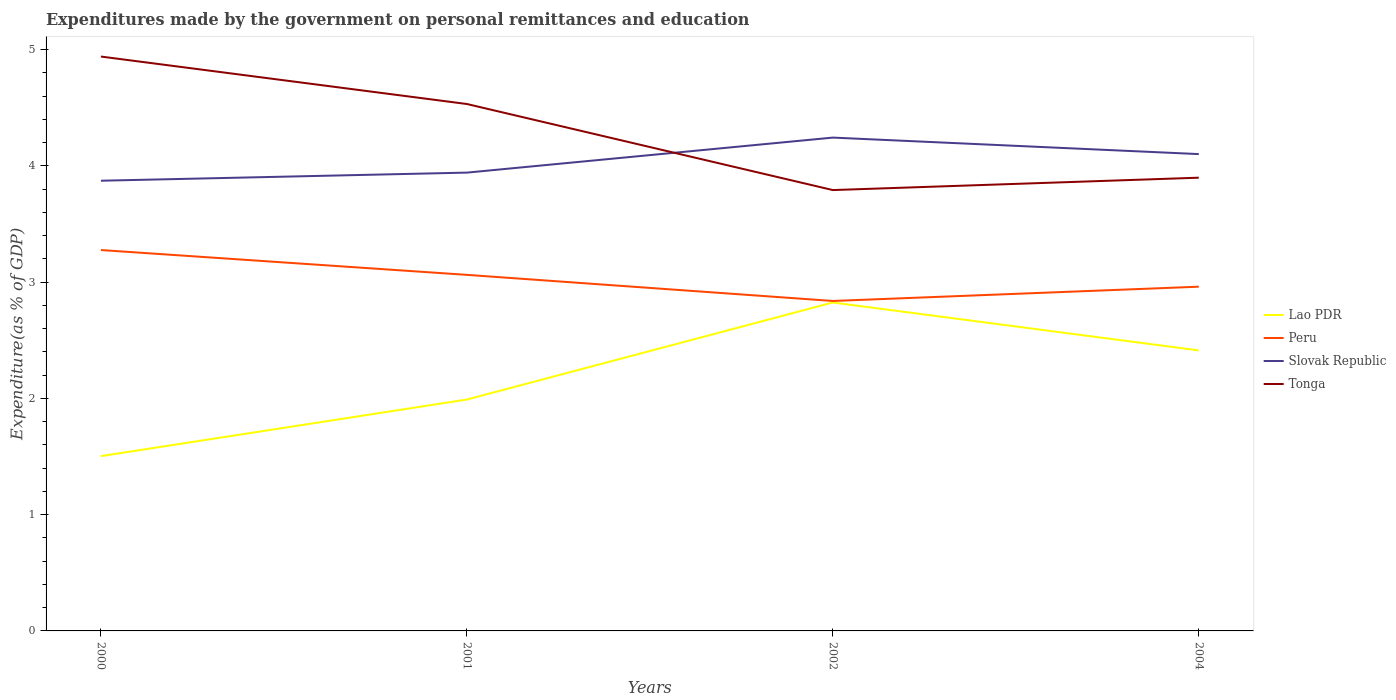How many different coloured lines are there?
Provide a short and direct response. 4. Does the line corresponding to Tonga intersect with the line corresponding to Lao PDR?
Ensure brevity in your answer.  No. Is the number of lines equal to the number of legend labels?
Give a very brief answer. Yes. Across all years, what is the maximum expenditures made by the government on personal remittances and education in Slovak Republic?
Give a very brief answer. 3.87. In which year was the expenditures made by the government on personal remittances and education in Tonga maximum?
Give a very brief answer. 2002. What is the total expenditures made by the government on personal remittances and education in Tonga in the graph?
Provide a succinct answer. 1.15. What is the difference between the highest and the second highest expenditures made by the government on personal remittances and education in Peru?
Offer a very short reply. 0.44. What is the difference between the highest and the lowest expenditures made by the government on personal remittances and education in Slovak Republic?
Ensure brevity in your answer.  2. Is the expenditures made by the government on personal remittances and education in Slovak Republic strictly greater than the expenditures made by the government on personal remittances and education in Peru over the years?
Your answer should be very brief. No. Does the graph contain any zero values?
Keep it short and to the point. No. Does the graph contain grids?
Your response must be concise. No. How are the legend labels stacked?
Offer a very short reply. Vertical. What is the title of the graph?
Make the answer very short. Expenditures made by the government on personal remittances and education. What is the label or title of the Y-axis?
Offer a very short reply. Expenditure(as % of GDP). What is the Expenditure(as % of GDP) in Lao PDR in 2000?
Your answer should be compact. 1.5. What is the Expenditure(as % of GDP) of Peru in 2000?
Provide a succinct answer. 3.28. What is the Expenditure(as % of GDP) of Slovak Republic in 2000?
Your response must be concise. 3.87. What is the Expenditure(as % of GDP) of Tonga in 2000?
Ensure brevity in your answer.  4.94. What is the Expenditure(as % of GDP) in Lao PDR in 2001?
Offer a very short reply. 1.99. What is the Expenditure(as % of GDP) in Peru in 2001?
Keep it short and to the point. 3.06. What is the Expenditure(as % of GDP) in Slovak Republic in 2001?
Keep it short and to the point. 3.94. What is the Expenditure(as % of GDP) in Tonga in 2001?
Your answer should be compact. 4.53. What is the Expenditure(as % of GDP) of Lao PDR in 2002?
Offer a very short reply. 2.83. What is the Expenditure(as % of GDP) in Peru in 2002?
Offer a terse response. 2.84. What is the Expenditure(as % of GDP) in Slovak Republic in 2002?
Ensure brevity in your answer.  4.24. What is the Expenditure(as % of GDP) of Tonga in 2002?
Provide a short and direct response. 3.79. What is the Expenditure(as % of GDP) of Lao PDR in 2004?
Provide a succinct answer. 2.41. What is the Expenditure(as % of GDP) of Peru in 2004?
Your answer should be compact. 2.96. What is the Expenditure(as % of GDP) in Slovak Republic in 2004?
Your answer should be very brief. 4.1. What is the Expenditure(as % of GDP) in Tonga in 2004?
Offer a very short reply. 3.9. Across all years, what is the maximum Expenditure(as % of GDP) of Lao PDR?
Your response must be concise. 2.83. Across all years, what is the maximum Expenditure(as % of GDP) of Peru?
Your answer should be very brief. 3.28. Across all years, what is the maximum Expenditure(as % of GDP) in Slovak Republic?
Offer a very short reply. 4.24. Across all years, what is the maximum Expenditure(as % of GDP) of Tonga?
Provide a succinct answer. 4.94. Across all years, what is the minimum Expenditure(as % of GDP) of Lao PDR?
Keep it short and to the point. 1.5. Across all years, what is the minimum Expenditure(as % of GDP) of Peru?
Provide a short and direct response. 2.84. Across all years, what is the minimum Expenditure(as % of GDP) in Slovak Republic?
Ensure brevity in your answer.  3.87. Across all years, what is the minimum Expenditure(as % of GDP) of Tonga?
Your answer should be compact. 3.79. What is the total Expenditure(as % of GDP) in Lao PDR in the graph?
Ensure brevity in your answer.  8.73. What is the total Expenditure(as % of GDP) of Peru in the graph?
Offer a terse response. 12.14. What is the total Expenditure(as % of GDP) in Slovak Republic in the graph?
Ensure brevity in your answer.  16.16. What is the total Expenditure(as % of GDP) of Tonga in the graph?
Provide a succinct answer. 17.16. What is the difference between the Expenditure(as % of GDP) of Lao PDR in 2000 and that in 2001?
Offer a very short reply. -0.49. What is the difference between the Expenditure(as % of GDP) of Peru in 2000 and that in 2001?
Your response must be concise. 0.21. What is the difference between the Expenditure(as % of GDP) of Slovak Republic in 2000 and that in 2001?
Offer a terse response. -0.07. What is the difference between the Expenditure(as % of GDP) of Tonga in 2000 and that in 2001?
Make the answer very short. 0.41. What is the difference between the Expenditure(as % of GDP) in Lao PDR in 2000 and that in 2002?
Keep it short and to the point. -1.32. What is the difference between the Expenditure(as % of GDP) in Peru in 2000 and that in 2002?
Make the answer very short. 0.44. What is the difference between the Expenditure(as % of GDP) in Slovak Republic in 2000 and that in 2002?
Keep it short and to the point. -0.37. What is the difference between the Expenditure(as % of GDP) in Tonga in 2000 and that in 2002?
Offer a very short reply. 1.15. What is the difference between the Expenditure(as % of GDP) in Lao PDR in 2000 and that in 2004?
Offer a terse response. -0.91. What is the difference between the Expenditure(as % of GDP) in Peru in 2000 and that in 2004?
Make the answer very short. 0.32. What is the difference between the Expenditure(as % of GDP) of Slovak Republic in 2000 and that in 2004?
Offer a very short reply. -0.23. What is the difference between the Expenditure(as % of GDP) of Tonga in 2000 and that in 2004?
Your answer should be compact. 1.04. What is the difference between the Expenditure(as % of GDP) in Lao PDR in 2001 and that in 2002?
Your answer should be compact. -0.83. What is the difference between the Expenditure(as % of GDP) of Peru in 2001 and that in 2002?
Your answer should be compact. 0.22. What is the difference between the Expenditure(as % of GDP) of Slovak Republic in 2001 and that in 2002?
Offer a terse response. -0.3. What is the difference between the Expenditure(as % of GDP) in Tonga in 2001 and that in 2002?
Your response must be concise. 0.74. What is the difference between the Expenditure(as % of GDP) of Lao PDR in 2001 and that in 2004?
Your answer should be compact. -0.42. What is the difference between the Expenditure(as % of GDP) in Peru in 2001 and that in 2004?
Offer a terse response. 0.1. What is the difference between the Expenditure(as % of GDP) of Slovak Republic in 2001 and that in 2004?
Offer a terse response. -0.16. What is the difference between the Expenditure(as % of GDP) of Tonga in 2001 and that in 2004?
Offer a very short reply. 0.63. What is the difference between the Expenditure(as % of GDP) of Lao PDR in 2002 and that in 2004?
Provide a short and direct response. 0.41. What is the difference between the Expenditure(as % of GDP) in Peru in 2002 and that in 2004?
Provide a succinct answer. -0.12. What is the difference between the Expenditure(as % of GDP) in Slovak Republic in 2002 and that in 2004?
Ensure brevity in your answer.  0.14. What is the difference between the Expenditure(as % of GDP) of Tonga in 2002 and that in 2004?
Offer a terse response. -0.11. What is the difference between the Expenditure(as % of GDP) of Lao PDR in 2000 and the Expenditure(as % of GDP) of Peru in 2001?
Keep it short and to the point. -1.56. What is the difference between the Expenditure(as % of GDP) in Lao PDR in 2000 and the Expenditure(as % of GDP) in Slovak Republic in 2001?
Make the answer very short. -2.44. What is the difference between the Expenditure(as % of GDP) of Lao PDR in 2000 and the Expenditure(as % of GDP) of Tonga in 2001?
Offer a terse response. -3.03. What is the difference between the Expenditure(as % of GDP) of Peru in 2000 and the Expenditure(as % of GDP) of Slovak Republic in 2001?
Offer a very short reply. -0.67. What is the difference between the Expenditure(as % of GDP) of Peru in 2000 and the Expenditure(as % of GDP) of Tonga in 2001?
Offer a very short reply. -1.26. What is the difference between the Expenditure(as % of GDP) of Slovak Republic in 2000 and the Expenditure(as % of GDP) of Tonga in 2001?
Your answer should be very brief. -0.66. What is the difference between the Expenditure(as % of GDP) of Lao PDR in 2000 and the Expenditure(as % of GDP) of Peru in 2002?
Offer a terse response. -1.33. What is the difference between the Expenditure(as % of GDP) in Lao PDR in 2000 and the Expenditure(as % of GDP) in Slovak Republic in 2002?
Make the answer very short. -2.74. What is the difference between the Expenditure(as % of GDP) in Lao PDR in 2000 and the Expenditure(as % of GDP) in Tonga in 2002?
Provide a succinct answer. -2.29. What is the difference between the Expenditure(as % of GDP) in Peru in 2000 and the Expenditure(as % of GDP) in Slovak Republic in 2002?
Your answer should be compact. -0.97. What is the difference between the Expenditure(as % of GDP) of Peru in 2000 and the Expenditure(as % of GDP) of Tonga in 2002?
Offer a terse response. -0.52. What is the difference between the Expenditure(as % of GDP) in Slovak Republic in 2000 and the Expenditure(as % of GDP) in Tonga in 2002?
Your response must be concise. 0.08. What is the difference between the Expenditure(as % of GDP) of Lao PDR in 2000 and the Expenditure(as % of GDP) of Peru in 2004?
Your answer should be very brief. -1.46. What is the difference between the Expenditure(as % of GDP) in Lao PDR in 2000 and the Expenditure(as % of GDP) in Slovak Republic in 2004?
Give a very brief answer. -2.6. What is the difference between the Expenditure(as % of GDP) in Lao PDR in 2000 and the Expenditure(as % of GDP) in Tonga in 2004?
Your answer should be compact. -2.4. What is the difference between the Expenditure(as % of GDP) in Peru in 2000 and the Expenditure(as % of GDP) in Slovak Republic in 2004?
Offer a very short reply. -0.83. What is the difference between the Expenditure(as % of GDP) of Peru in 2000 and the Expenditure(as % of GDP) of Tonga in 2004?
Give a very brief answer. -0.62. What is the difference between the Expenditure(as % of GDP) in Slovak Republic in 2000 and the Expenditure(as % of GDP) in Tonga in 2004?
Provide a succinct answer. -0.03. What is the difference between the Expenditure(as % of GDP) in Lao PDR in 2001 and the Expenditure(as % of GDP) in Peru in 2002?
Provide a succinct answer. -0.85. What is the difference between the Expenditure(as % of GDP) in Lao PDR in 2001 and the Expenditure(as % of GDP) in Slovak Republic in 2002?
Make the answer very short. -2.25. What is the difference between the Expenditure(as % of GDP) of Lao PDR in 2001 and the Expenditure(as % of GDP) of Tonga in 2002?
Your response must be concise. -1.8. What is the difference between the Expenditure(as % of GDP) in Peru in 2001 and the Expenditure(as % of GDP) in Slovak Republic in 2002?
Keep it short and to the point. -1.18. What is the difference between the Expenditure(as % of GDP) of Peru in 2001 and the Expenditure(as % of GDP) of Tonga in 2002?
Make the answer very short. -0.73. What is the difference between the Expenditure(as % of GDP) of Slovak Republic in 2001 and the Expenditure(as % of GDP) of Tonga in 2002?
Make the answer very short. 0.15. What is the difference between the Expenditure(as % of GDP) in Lao PDR in 2001 and the Expenditure(as % of GDP) in Peru in 2004?
Give a very brief answer. -0.97. What is the difference between the Expenditure(as % of GDP) of Lao PDR in 2001 and the Expenditure(as % of GDP) of Slovak Republic in 2004?
Provide a succinct answer. -2.11. What is the difference between the Expenditure(as % of GDP) of Lao PDR in 2001 and the Expenditure(as % of GDP) of Tonga in 2004?
Provide a succinct answer. -1.91. What is the difference between the Expenditure(as % of GDP) of Peru in 2001 and the Expenditure(as % of GDP) of Slovak Republic in 2004?
Make the answer very short. -1.04. What is the difference between the Expenditure(as % of GDP) of Peru in 2001 and the Expenditure(as % of GDP) of Tonga in 2004?
Provide a succinct answer. -0.84. What is the difference between the Expenditure(as % of GDP) in Slovak Republic in 2001 and the Expenditure(as % of GDP) in Tonga in 2004?
Your answer should be very brief. 0.04. What is the difference between the Expenditure(as % of GDP) of Lao PDR in 2002 and the Expenditure(as % of GDP) of Peru in 2004?
Keep it short and to the point. -0.14. What is the difference between the Expenditure(as % of GDP) of Lao PDR in 2002 and the Expenditure(as % of GDP) of Slovak Republic in 2004?
Keep it short and to the point. -1.28. What is the difference between the Expenditure(as % of GDP) of Lao PDR in 2002 and the Expenditure(as % of GDP) of Tonga in 2004?
Your answer should be compact. -1.07. What is the difference between the Expenditure(as % of GDP) of Peru in 2002 and the Expenditure(as % of GDP) of Slovak Republic in 2004?
Offer a terse response. -1.26. What is the difference between the Expenditure(as % of GDP) of Peru in 2002 and the Expenditure(as % of GDP) of Tonga in 2004?
Make the answer very short. -1.06. What is the difference between the Expenditure(as % of GDP) in Slovak Republic in 2002 and the Expenditure(as % of GDP) in Tonga in 2004?
Provide a short and direct response. 0.34. What is the average Expenditure(as % of GDP) of Lao PDR per year?
Offer a very short reply. 2.18. What is the average Expenditure(as % of GDP) of Peru per year?
Your answer should be very brief. 3.03. What is the average Expenditure(as % of GDP) in Slovak Republic per year?
Provide a succinct answer. 4.04. What is the average Expenditure(as % of GDP) in Tonga per year?
Ensure brevity in your answer.  4.29. In the year 2000, what is the difference between the Expenditure(as % of GDP) in Lao PDR and Expenditure(as % of GDP) in Peru?
Your response must be concise. -1.77. In the year 2000, what is the difference between the Expenditure(as % of GDP) in Lao PDR and Expenditure(as % of GDP) in Slovak Republic?
Ensure brevity in your answer.  -2.37. In the year 2000, what is the difference between the Expenditure(as % of GDP) in Lao PDR and Expenditure(as % of GDP) in Tonga?
Provide a succinct answer. -3.44. In the year 2000, what is the difference between the Expenditure(as % of GDP) of Peru and Expenditure(as % of GDP) of Slovak Republic?
Offer a very short reply. -0.6. In the year 2000, what is the difference between the Expenditure(as % of GDP) of Peru and Expenditure(as % of GDP) of Tonga?
Ensure brevity in your answer.  -1.66. In the year 2000, what is the difference between the Expenditure(as % of GDP) in Slovak Republic and Expenditure(as % of GDP) in Tonga?
Your response must be concise. -1.07. In the year 2001, what is the difference between the Expenditure(as % of GDP) in Lao PDR and Expenditure(as % of GDP) in Peru?
Ensure brevity in your answer.  -1.07. In the year 2001, what is the difference between the Expenditure(as % of GDP) in Lao PDR and Expenditure(as % of GDP) in Slovak Republic?
Give a very brief answer. -1.95. In the year 2001, what is the difference between the Expenditure(as % of GDP) of Lao PDR and Expenditure(as % of GDP) of Tonga?
Offer a very short reply. -2.54. In the year 2001, what is the difference between the Expenditure(as % of GDP) of Peru and Expenditure(as % of GDP) of Slovak Republic?
Your answer should be very brief. -0.88. In the year 2001, what is the difference between the Expenditure(as % of GDP) of Peru and Expenditure(as % of GDP) of Tonga?
Make the answer very short. -1.47. In the year 2001, what is the difference between the Expenditure(as % of GDP) of Slovak Republic and Expenditure(as % of GDP) of Tonga?
Your answer should be compact. -0.59. In the year 2002, what is the difference between the Expenditure(as % of GDP) in Lao PDR and Expenditure(as % of GDP) in Peru?
Make the answer very short. -0.01. In the year 2002, what is the difference between the Expenditure(as % of GDP) in Lao PDR and Expenditure(as % of GDP) in Slovak Republic?
Offer a very short reply. -1.42. In the year 2002, what is the difference between the Expenditure(as % of GDP) of Lao PDR and Expenditure(as % of GDP) of Tonga?
Offer a very short reply. -0.97. In the year 2002, what is the difference between the Expenditure(as % of GDP) of Peru and Expenditure(as % of GDP) of Slovak Republic?
Ensure brevity in your answer.  -1.41. In the year 2002, what is the difference between the Expenditure(as % of GDP) of Peru and Expenditure(as % of GDP) of Tonga?
Your answer should be compact. -0.95. In the year 2002, what is the difference between the Expenditure(as % of GDP) of Slovak Republic and Expenditure(as % of GDP) of Tonga?
Provide a short and direct response. 0.45. In the year 2004, what is the difference between the Expenditure(as % of GDP) of Lao PDR and Expenditure(as % of GDP) of Peru?
Keep it short and to the point. -0.55. In the year 2004, what is the difference between the Expenditure(as % of GDP) of Lao PDR and Expenditure(as % of GDP) of Slovak Republic?
Offer a very short reply. -1.69. In the year 2004, what is the difference between the Expenditure(as % of GDP) of Lao PDR and Expenditure(as % of GDP) of Tonga?
Keep it short and to the point. -1.49. In the year 2004, what is the difference between the Expenditure(as % of GDP) in Peru and Expenditure(as % of GDP) in Slovak Republic?
Your response must be concise. -1.14. In the year 2004, what is the difference between the Expenditure(as % of GDP) of Peru and Expenditure(as % of GDP) of Tonga?
Your answer should be very brief. -0.94. In the year 2004, what is the difference between the Expenditure(as % of GDP) in Slovak Republic and Expenditure(as % of GDP) in Tonga?
Provide a succinct answer. 0.2. What is the ratio of the Expenditure(as % of GDP) of Lao PDR in 2000 to that in 2001?
Offer a very short reply. 0.76. What is the ratio of the Expenditure(as % of GDP) in Peru in 2000 to that in 2001?
Keep it short and to the point. 1.07. What is the ratio of the Expenditure(as % of GDP) of Slovak Republic in 2000 to that in 2001?
Provide a short and direct response. 0.98. What is the ratio of the Expenditure(as % of GDP) of Tonga in 2000 to that in 2001?
Provide a succinct answer. 1.09. What is the ratio of the Expenditure(as % of GDP) of Lao PDR in 2000 to that in 2002?
Offer a terse response. 0.53. What is the ratio of the Expenditure(as % of GDP) in Peru in 2000 to that in 2002?
Your answer should be very brief. 1.15. What is the ratio of the Expenditure(as % of GDP) of Slovak Republic in 2000 to that in 2002?
Make the answer very short. 0.91. What is the ratio of the Expenditure(as % of GDP) in Tonga in 2000 to that in 2002?
Give a very brief answer. 1.3. What is the ratio of the Expenditure(as % of GDP) in Lao PDR in 2000 to that in 2004?
Give a very brief answer. 0.62. What is the ratio of the Expenditure(as % of GDP) in Peru in 2000 to that in 2004?
Give a very brief answer. 1.11. What is the ratio of the Expenditure(as % of GDP) of Slovak Republic in 2000 to that in 2004?
Your response must be concise. 0.94. What is the ratio of the Expenditure(as % of GDP) in Tonga in 2000 to that in 2004?
Ensure brevity in your answer.  1.27. What is the ratio of the Expenditure(as % of GDP) in Lao PDR in 2001 to that in 2002?
Offer a very short reply. 0.7. What is the ratio of the Expenditure(as % of GDP) of Peru in 2001 to that in 2002?
Your answer should be very brief. 1.08. What is the ratio of the Expenditure(as % of GDP) in Slovak Republic in 2001 to that in 2002?
Make the answer very short. 0.93. What is the ratio of the Expenditure(as % of GDP) in Tonga in 2001 to that in 2002?
Provide a short and direct response. 1.2. What is the ratio of the Expenditure(as % of GDP) of Lao PDR in 2001 to that in 2004?
Provide a short and direct response. 0.82. What is the ratio of the Expenditure(as % of GDP) in Peru in 2001 to that in 2004?
Offer a very short reply. 1.03. What is the ratio of the Expenditure(as % of GDP) in Slovak Republic in 2001 to that in 2004?
Offer a terse response. 0.96. What is the ratio of the Expenditure(as % of GDP) of Tonga in 2001 to that in 2004?
Make the answer very short. 1.16. What is the ratio of the Expenditure(as % of GDP) of Lao PDR in 2002 to that in 2004?
Your answer should be very brief. 1.17. What is the ratio of the Expenditure(as % of GDP) in Peru in 2002 to that in 2004?
Offer a terse response. 0.96. What is the ratio of the Expenditure(as % of GDP) of Slovak Republic in 2002 to that in 2004?
Ensure brevity in your answer.  1.03. What is the ratio of the Expenditure(as % of GDP) in Tonga in 2002 to that in 2004?
Your answer should be compact. 0.97. What is the difference between the highest and the second highest Expenditure(as % of GDP) of Lao PDR?
Ensure brevity in your answer.  0.41. What is the difference between the highest and the second highest Expenditure(as % of GDP) in Peru?
Make the answer very short. 0.21. What is the difference between the highest and the second highest Expenditure(as % of GDP) in Slovak Republic?
Offer a very short reply. 0.14. What is the difference between the highest and the second highest Expenditure(as % of GDP) in Tonga?
Ensure brevity in your answer.  0.41. What is the difference between the highest and the lowest Expenditure(as % of GDP) in Lao PDR?
Your answer should be compact. 1.32. What is the difference between the highest and the lowest Expenditure(as % of GDP) in Peru?
Provide a succinct answer. 0.44. What is the difference between the highest and the lowest Expenditure(as % of GDP) in Slovak Republic?
Your answer should be compact. 0.37. What is the difference between the highest and the lowest Expenditure(as % of GDP) in Tonga?
Keep it short and to the point. 1.15. 